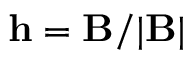Convert formula to latex. <formula><loc_0><loc_0><loc_500><loc_500>h = B / | B |</formula> 